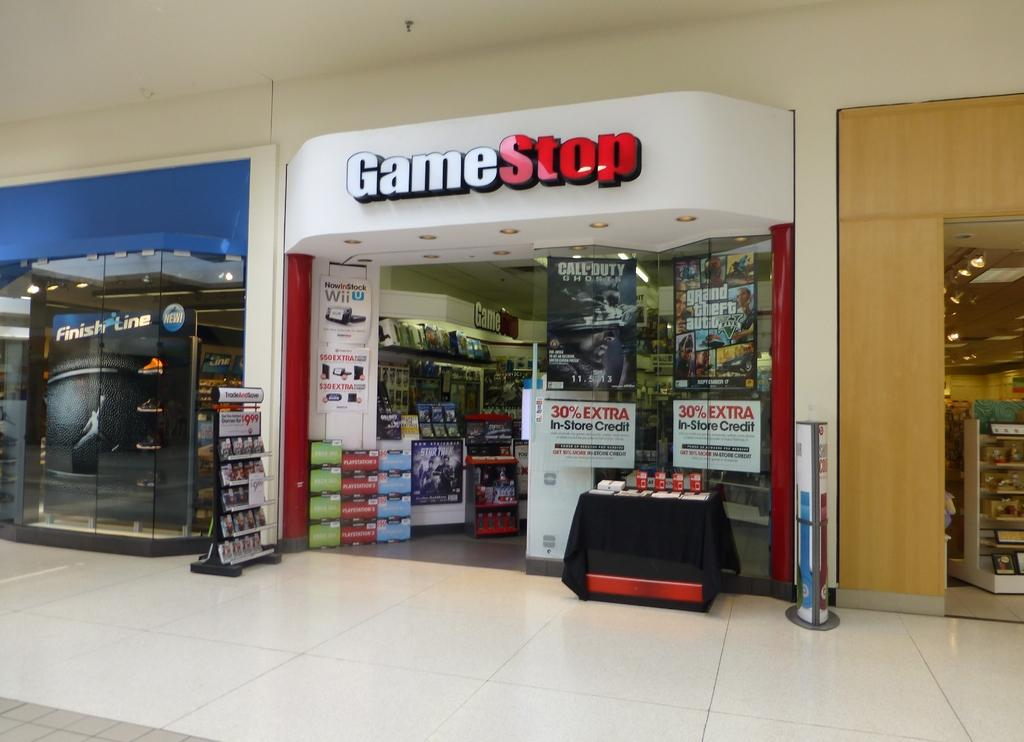What type of establishments can be seen in the image? There are stores in the image. How many farmers are present in the image? There are no farmers present in the image; it only shows stores. What is the distance between the stores in the image? The distance between the stores cannot be determined from the image alone, as it only provides a visual representation of the stores and not their spatial relationship. 